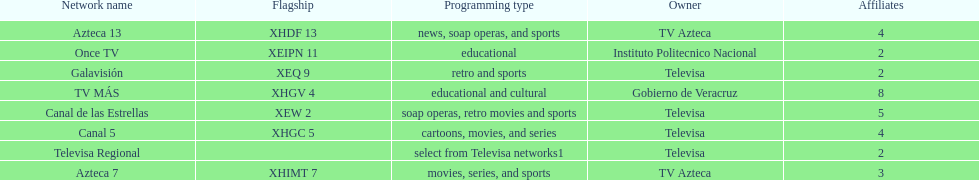How many networks have more affiliates than canal de las estrellas? 1. I'm looking to parse the entire table for insights. Could you assist me with that? {'header': ['Network name', 'Flagship', 'Programming type', 'Owner', 'Affiliates'], 'rows': [['Azteca 13', 'XHDF 13', 'news, soap operas, and sports', 'TV Azteca', '4'], ['Once TV', 'XEIPN 11', 'educational', 'Instituto Politecnico Nacional', '2'], ['Galavisión', 'XEQ 9', 'retro and sports', 'Televisa', '2'], ['TV MÁS', 'XHGV 4', 'educational and cultural', 'Gobierno de Veracruz', '8'], ['Canal de las Estrellas', 'XEW 2', 'soap operas, retro movies and sports', 'Televisa', '5'], ['Canal 5', 'XHGC 5', 'cartoons, movies, and series', 'Televisa', '4'], ['Televisa Regional', '', 'select from Televisa networks1', 'Televisa', '2'], ['Azteca 7', 'XHIMT 7', 'movies, series, and sports', 'TV Azteca', '3']]} 